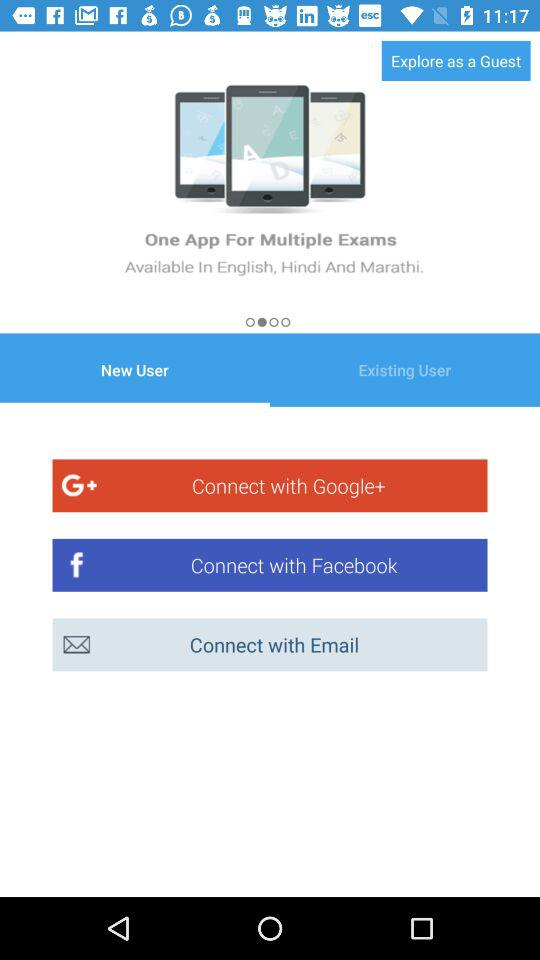Which tab is selected? The selected tab is "New User". 